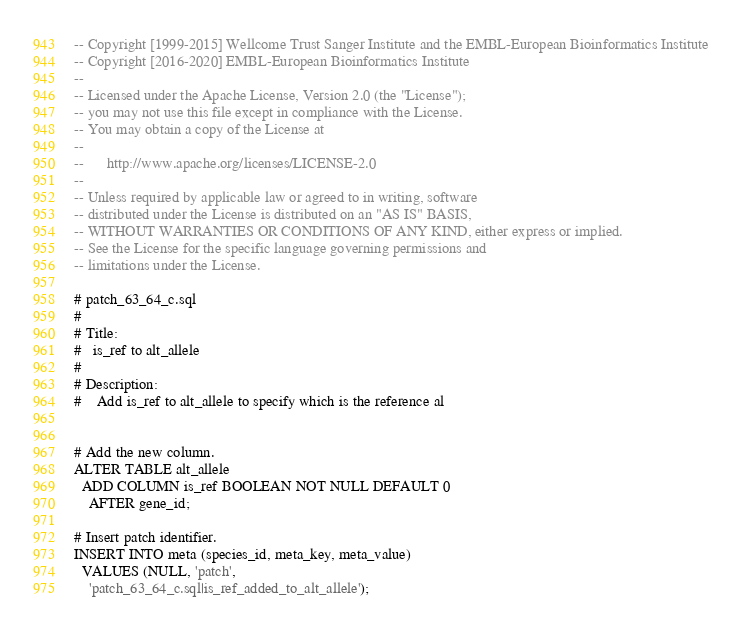<code> <loc_0><loc_0><loc_500><loc_500><_SQL_>-- Copyright [1999-2015] Wellcome Trust Sanger Institute and the EMBL-European Bioinformatics Institute
-- Copyright [2016-2020] EMBL-European Bioinformatics Institute
-- 
-- Licensed under the Apache License, Version 2.0 (the "License");
-- you may not use this file except in compliance with the License.
-- You may obtain a copy of the License at
-- 
--      http://www.apache.org/licenses/LICENSE-2.0
-- 
-- Unless required by applicable law or agreed to in writing, software
-- distributed under the License is distributed on an "AS IS" BASIS,
-- WITHOUT WARRANTIES OR CONDITIONS OF ANY KIND, either express or implied.
-- See the License for the specific language governing permissions and
-- limitations under the License.

# patch_63_64_c.sql
#
# Title:
#   is_ref to alt_allele 
#
# Description:
#    Add is_ref to alt_allele to specify which is the reference al


# Add the new column.
ALTER TABLE alt_allele
  ADD COLUMN is_ref BOOLEAN NOT NULL DEFAULT 0
    AFTER gene_id;

# Insert patch identifier.
INSERT INTO meta (species_id, meta_key, meta_value)
  VALUES (NULL, 'patch',
    'patch_63_64_c.sql|is_ref_added_to_alt_allele');
</code> 